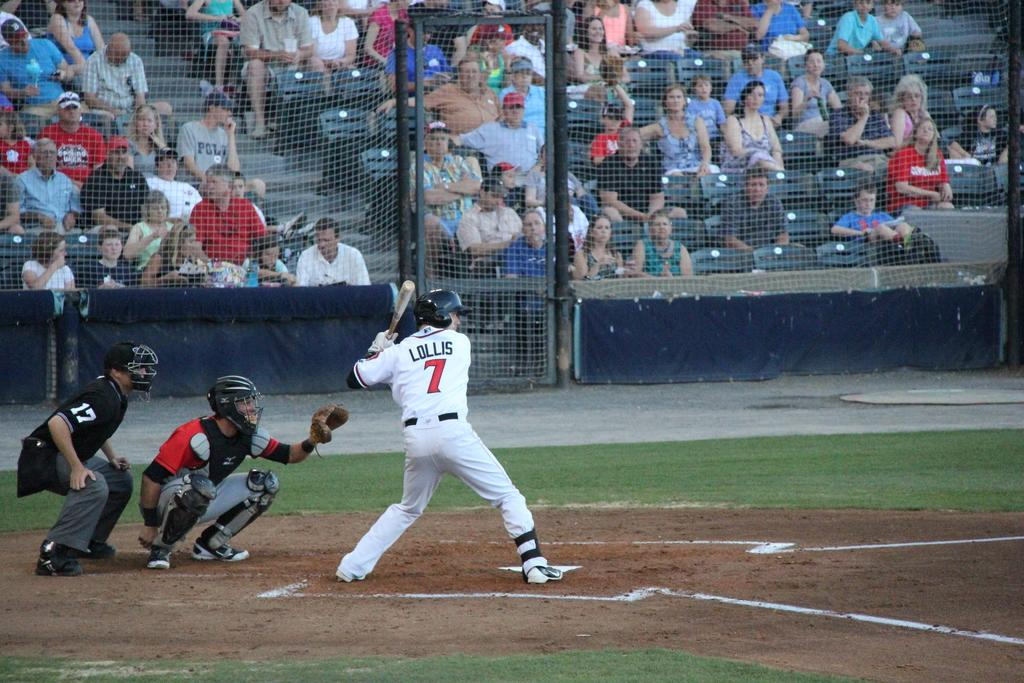Provide a one-sentence caption for the provided image. In the number 7 jersey, Lollis is taking his turn at bat. 